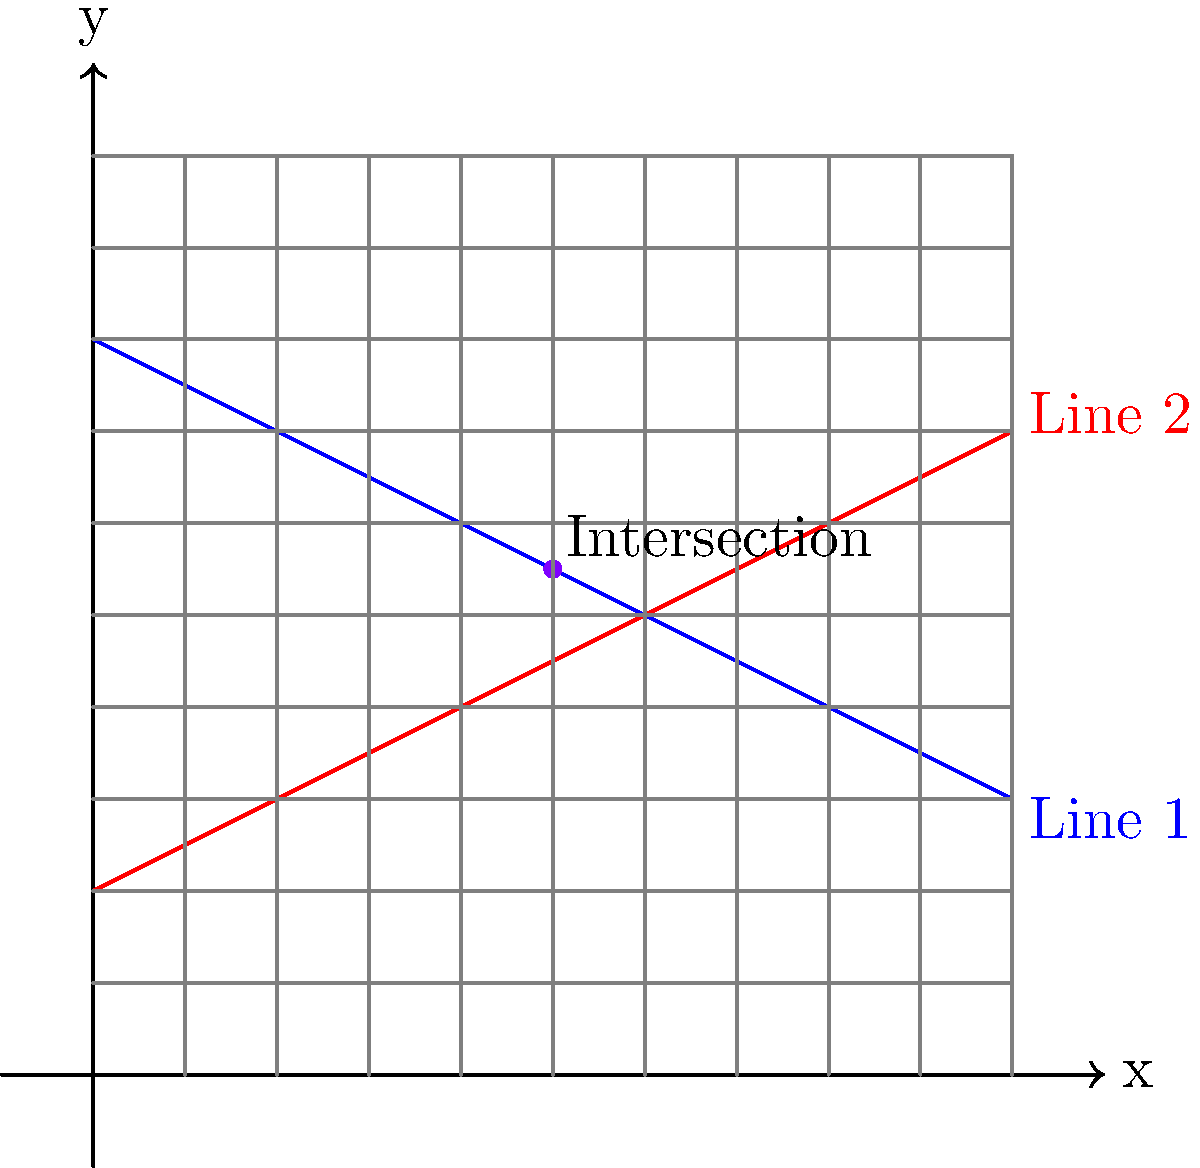As the greenhouse manager, you're planning a new irrigation system for a research project. Two irrigation lines are represented by the following equations:

Line 1: $y = -0.5x + 8$
Line 2: $y = 0.5x + 2$

At what point do these irrigation lines intersect, and what is the total length of pipe needed if each line extends from x = 0 to the intersection point? To solve this problem, we'll follow these steps:

1. Find the intersection point of the two lines:
   Set the equations equal to each other:
   $-0.5x + 8 = 0.5x + 2$
   $6 = x$
   Substitute x = 6 into either equation:
   $y = -0.5(6) + 8 = 5$
   The intersection point is (6, 5).

2. Calculate the length of Line 1 from (0, 8) to (6, 5):
   Use the distance formula: $d = \sqrt{(x_2-x_1)^2 + (y_2-y_1)^2}$
   $d_1 = \sqrt{(6-0)^2 + (5-8)^2} = \sqrt{36 + 9} = \sqrt{45} = 3\sqrt{5}$

3. Calculate the length of Line 2 from (0, 2) to (6, 5):
   $d_2 = \sqrt{(6-0)^2 + (5-2)^2} = \sqrt{36 + 9} = \sqrt{45} = 3\sqrt{5}$

4. Sum the lengths of both lines:
   Total length = $d_1 + d_2 = 3\sqrt{5} + 3\sqrt{5} = 6\sqrt{5}$

Therefore, the irrigation lines intersect at the point (6, 5), and the total length of pipe needed is $6\sqrt{5}$ units.
Answer: Intersection: (6, 5); Total pipe length: $6\sqrt{5}$ units 